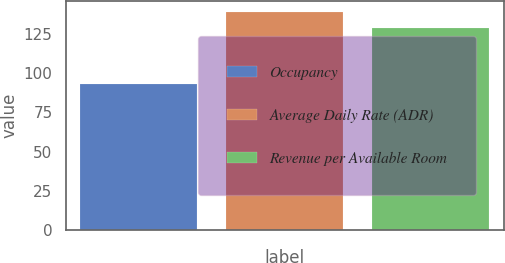Convert chart. <chart><loc_0><loc_0><loc_500><loc_500><bar_chart><fcel>Occupancy<fcel>Average Daily Rate (ADR)<fcel>Revenue per Available Room<nl><fcel>93<fcel>139<fcel>129<nl></chart> 